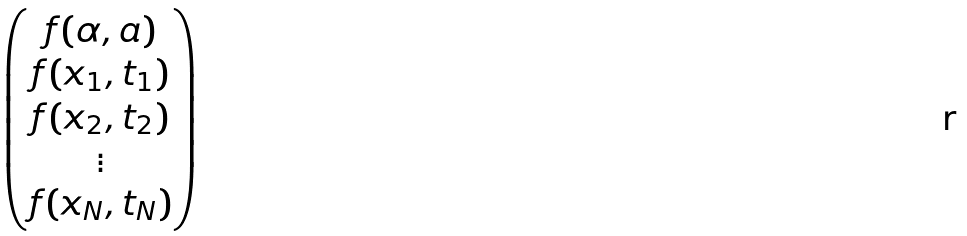Convert formula to latex. <formula><loc_0><loc_0><loc_500><loc_500>\begin{pmatrix} f ( \alpha , a ) \\ f ( x _ { 1 } , t _ { 1 } ) \\ f ( x _ { 2 } , t _ { 2 } ) \\ \vdots \\ f ( x _ { N } , t _ { N } ) \end{pmatrix}</formula> 